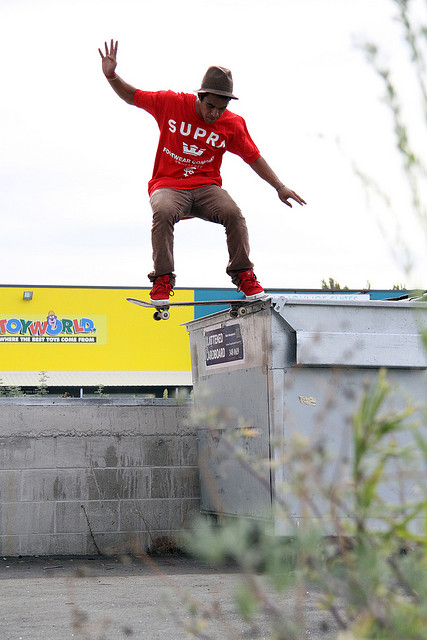Identify the text displayed in this image. SUPR TOYWORLD COME THE WHERE TOYS 10 34 